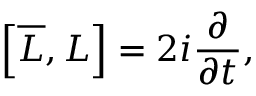<formula> <loc_0><loc_0><loc_500><loc_500>\left [ { \overline { L } } , L \right ] = 2 i { \frac { \partial } { \partial t } } ,</formula> 